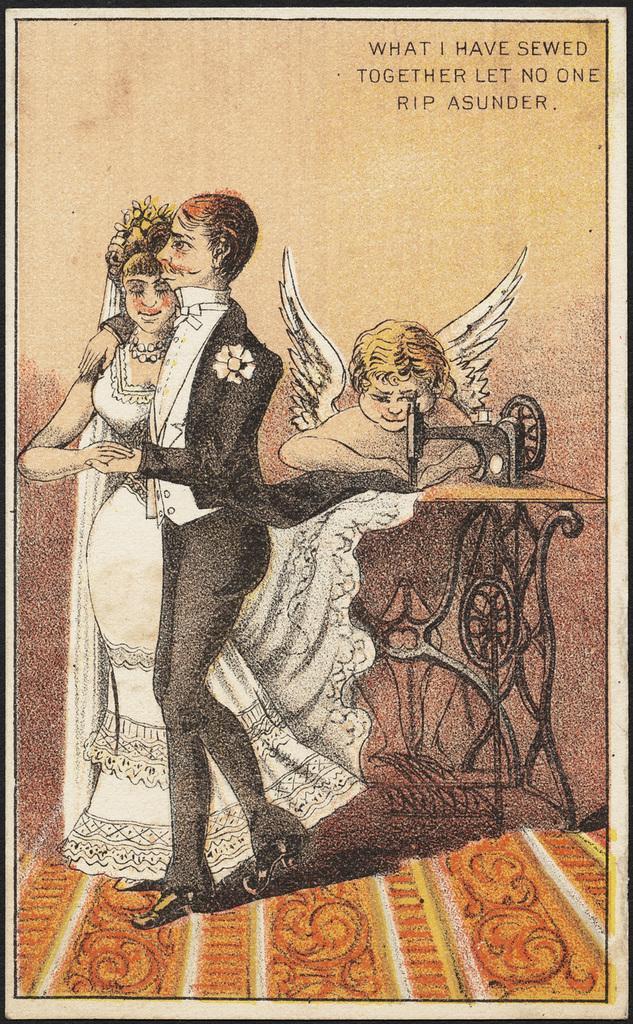Describe this image in one or two sentences. In this picture there is a poster. In that poster we can see the painting of a person who is wearing a suit, trouser and shoe. Beside him we can see a woman who is wearing a white dress. On the right we can see an angel. She is holding the clothes and stitching them with the machine. In the top right corner there is a watermark. 